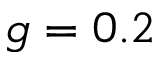Convert formula to latex. <formula><loc_0><loc_0><loc_500><loc_500>g = 0 . 2</formula> 